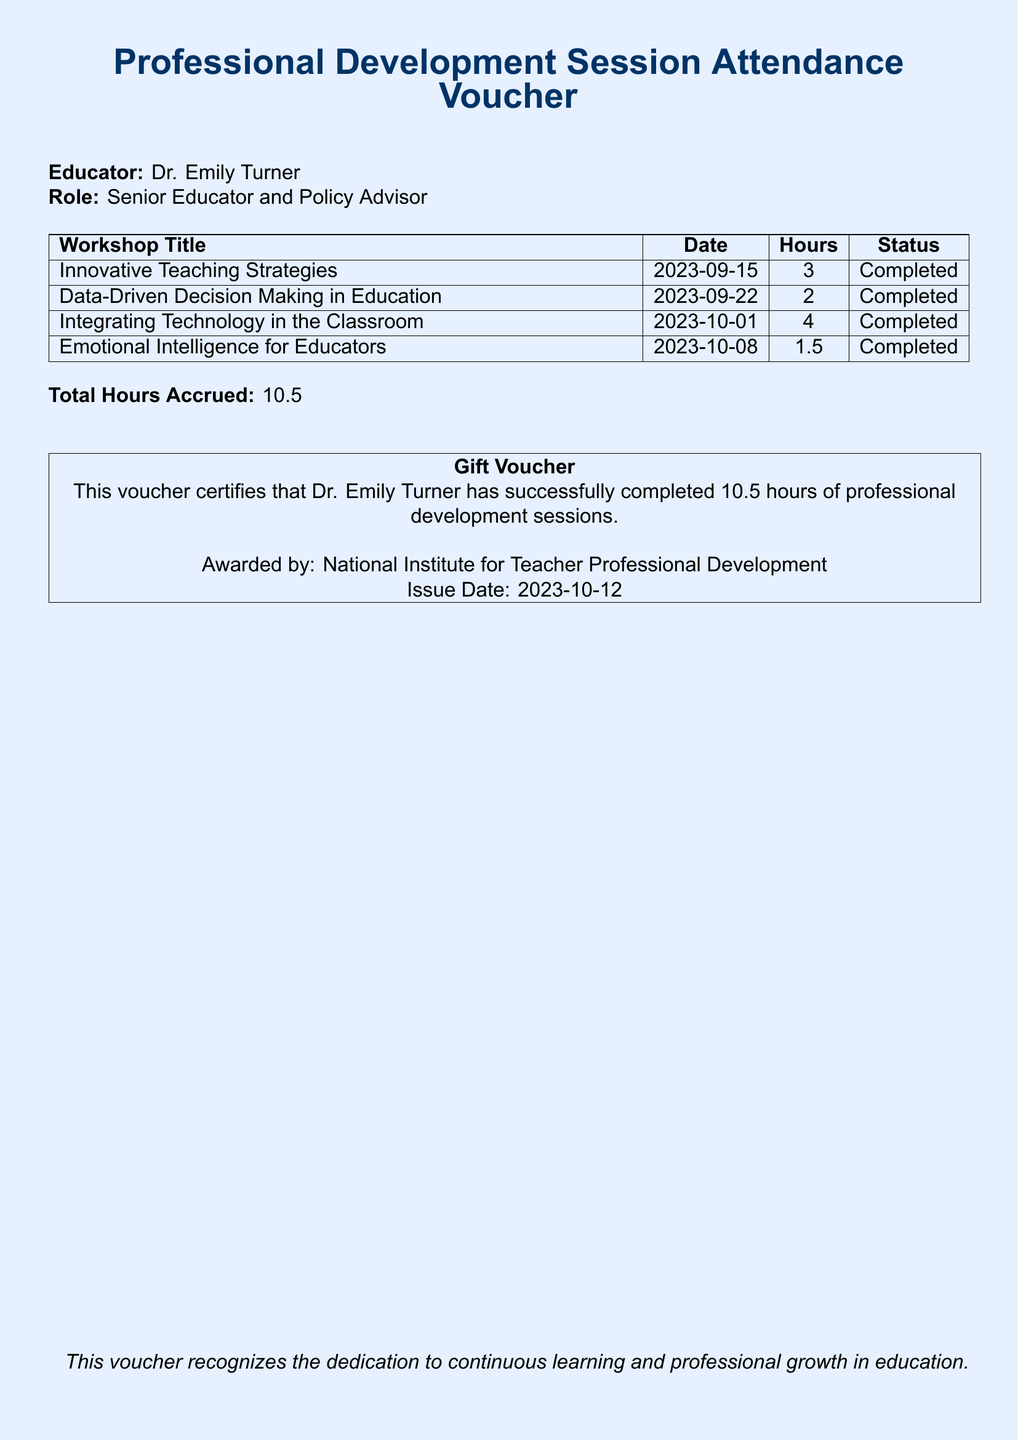What is the name of the educator? The document identifies the educator as Dr. Emily Turner.
Answer: Dr. Emily Turner What role does Dr. Emily Turner hold? The document specifies her role as Senior Educator and Policy Advisor.
Answer: Senior Educator and Policy Advisor How many workshops did Dr. Emily Turner attend? Counting the listed workshops in the table shows four workshops attended.
Answer: 4 What was the date of the first workshop? The first workshop's date is provided in the table as 2023-09-15.
Answer: 2023-09-15 What is the total number of hours accrued by Dr. Emily Turner? The document states the total hours accrued is 10.5.
Answer: 10.5 What is the status of the workshop on Emotional Intelligence for Educators? The status indicated for this workshop in the table is Completed.
Answer: Completed Who awarded the voucher? The document mentions that it was awarded by the National Institute for Teacher Professional Development.
Answer: National Institute for Teacher Professional Development On what date was the voucher issued? The issue date provided in the document is 2023-10-12.
Answer: 2023-10-12 What type of voucher is this? The document identifies this as a Gift Voucher.
Answer: Gift Voucher 